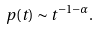Convert formula to latex. <formula><loc_0><loc_0><loc_500><loc_500>p ( t ) \sim t ^ { - 1 - \alpha } .</formula> 